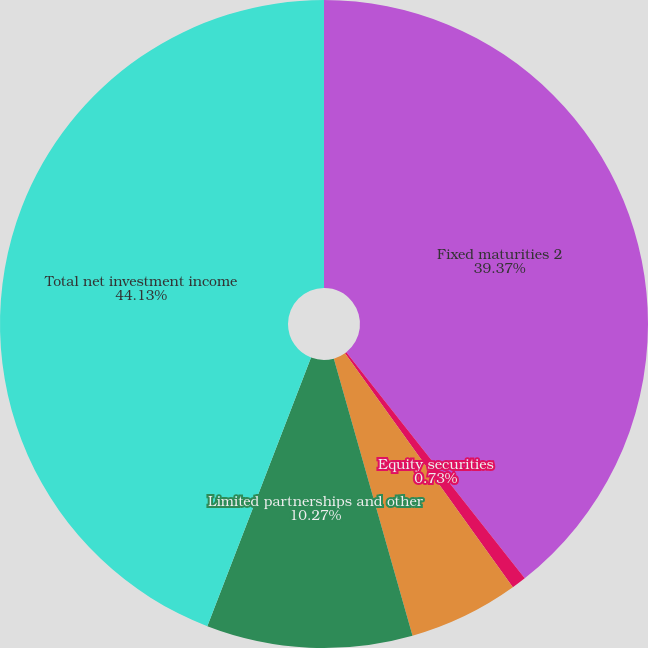Convert chart. <chart><loc_0><loc_0><loc_500><loc_500><pie_chart><fcel>Fixed maturities 2<fcel>Equity securities<fcel>Mortgage loans<fcel>Limited partnerships and other<fcel>Total net investment income<nl><fcel>39.37%<fcel>0.73%<fcel>5.5%<fcel>10.27%<fcel>44.14%<nl></chart> 